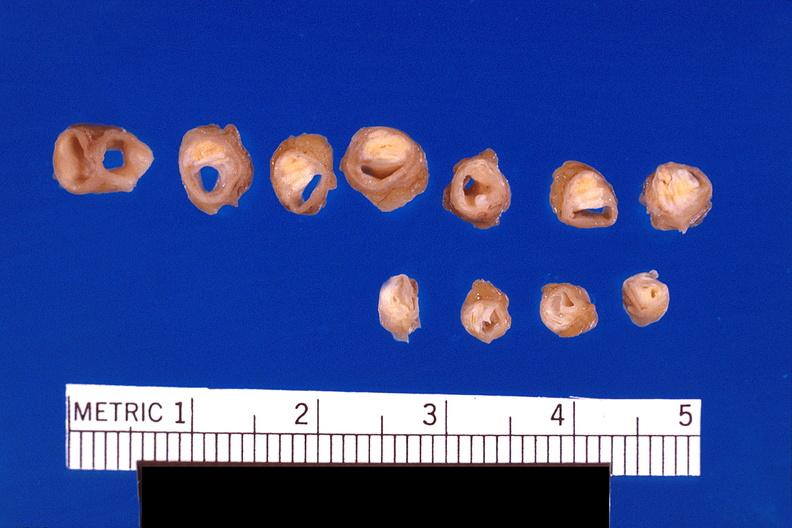what is atherosclerosis left?
Answer the question using a single word or phrase. Anterior descending coronary artery 